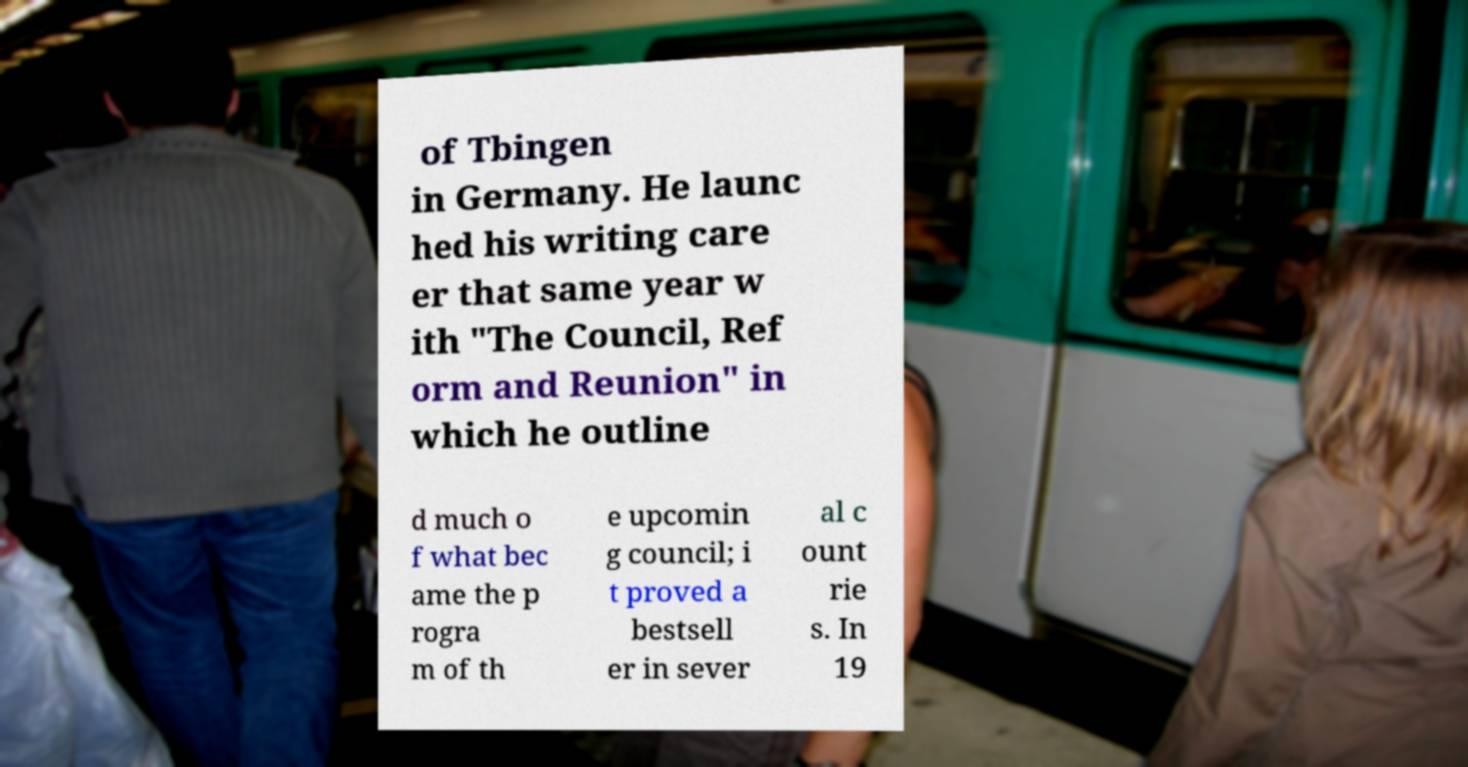Could you extract and type out the text from this image? of Tbingen in Germany. He launc hed his writing care er that same year w ith "The Council, Ref orm and Reunion" in which he outline d much o f what bec ame the p rogra m of th e upcomin g council; i t proved a bestsell er in sever al c ount rie s. In 19 